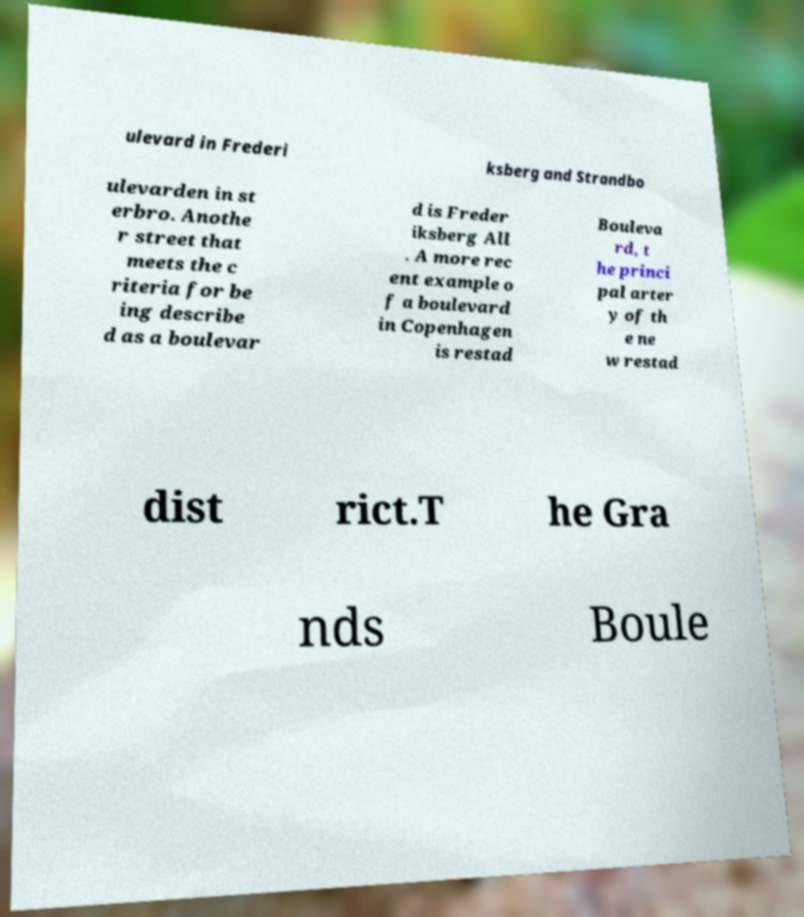There's text embedded in this image that I need extracted. Can you transcribe it verbatim? ulevard in Frederi ksberg and Strandbo ulevarden in st erbro. Anothe r street that meets the c riteria for be ing describe d as a boulevar d is Freder iksberg All . A more rec ent example o f a boulevard in Copenhagen is restad Bouleva rd, t he princi pal arter y of th e ne w restad dist rict.T he Gra nds Boule 